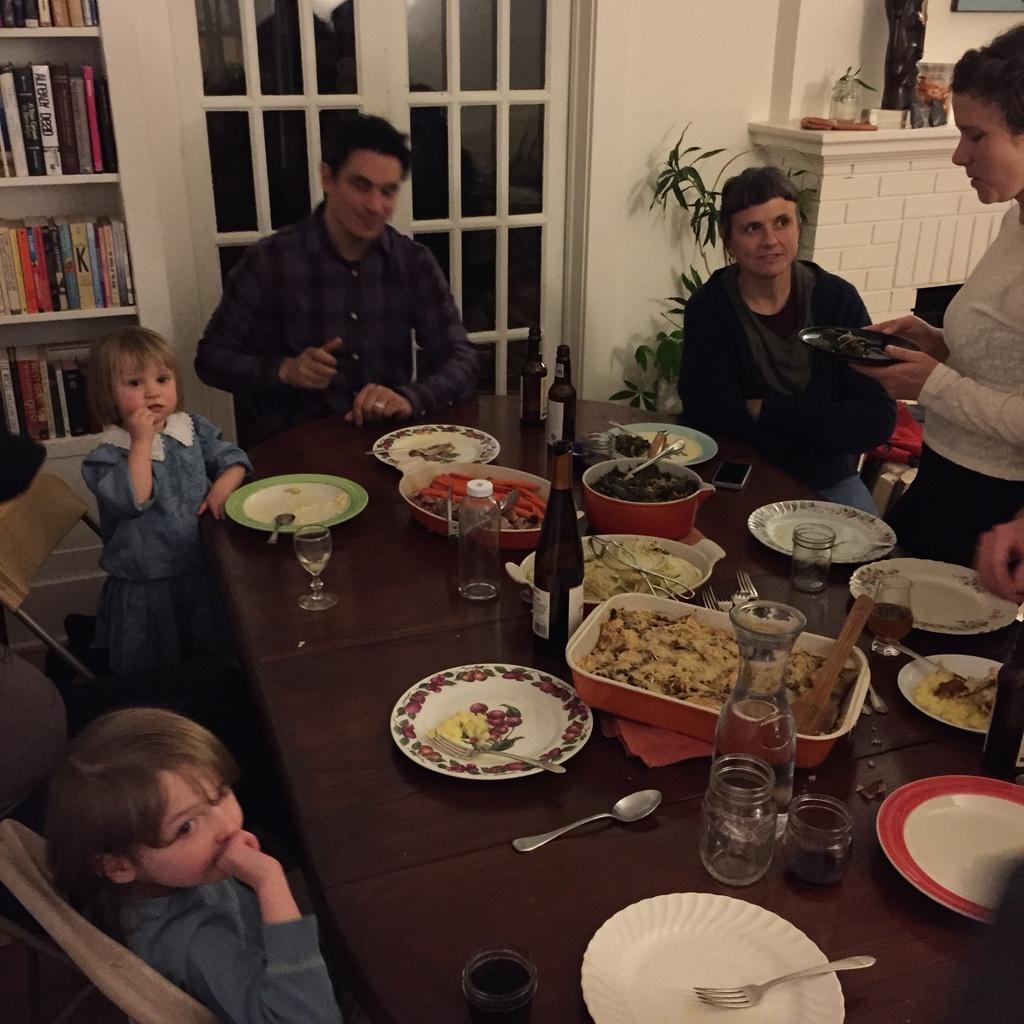How would you summarize this image in a sentence or two? In the image we can see there are people who are standing and sitting on chair and on the table there are food items, wine bottle, plate, spoon and fork. 